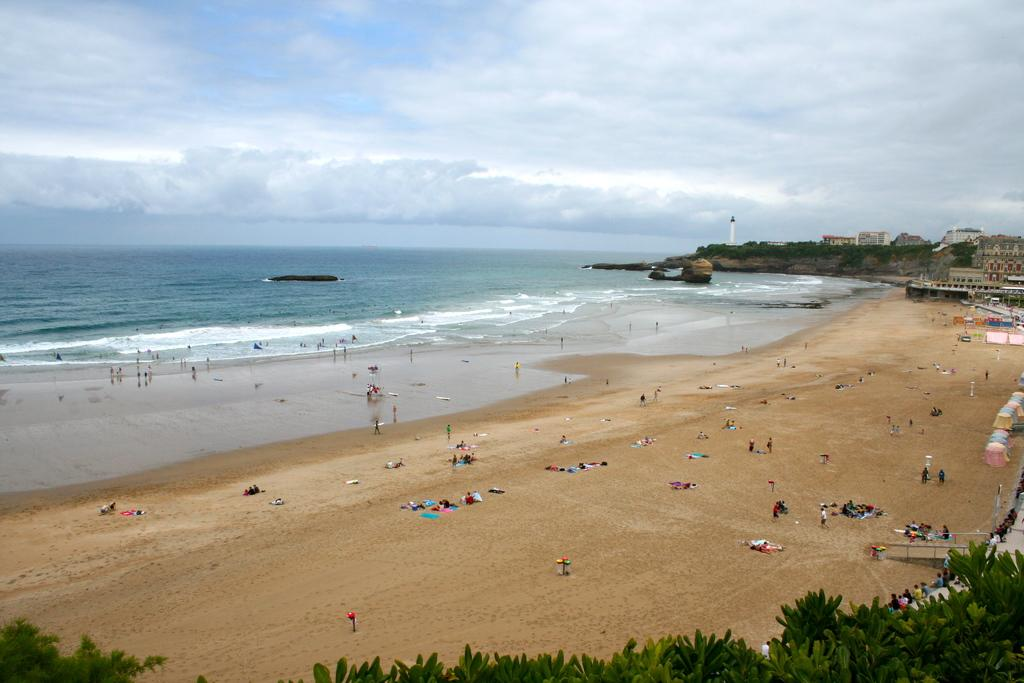What is the main setting of the picture? There is a sea shore in the picture. What can be seen at the sea shore? There are many people at the sea shore. What type of vegetation is visible in the picture? There are trees visible in the picture. What type of structures can be seen in the picture? There are buildings in the picture. Who is the owner of the fowl in the picture? There is no fowl present in the image, so it is not possible to determine the owner. 